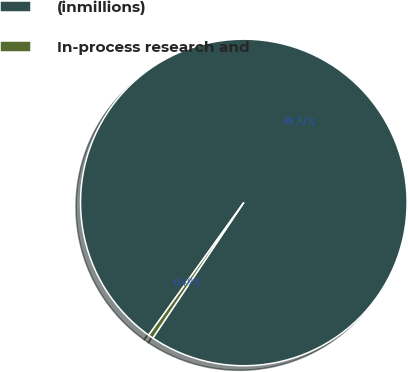<chart> <loc_0><loc_0><loc_500><loc_500><pie_chart><fcel>(inmillions)<fcel>In-process research and<nl><fcel>99.51%<fcel>0.49%<nl></chart> 